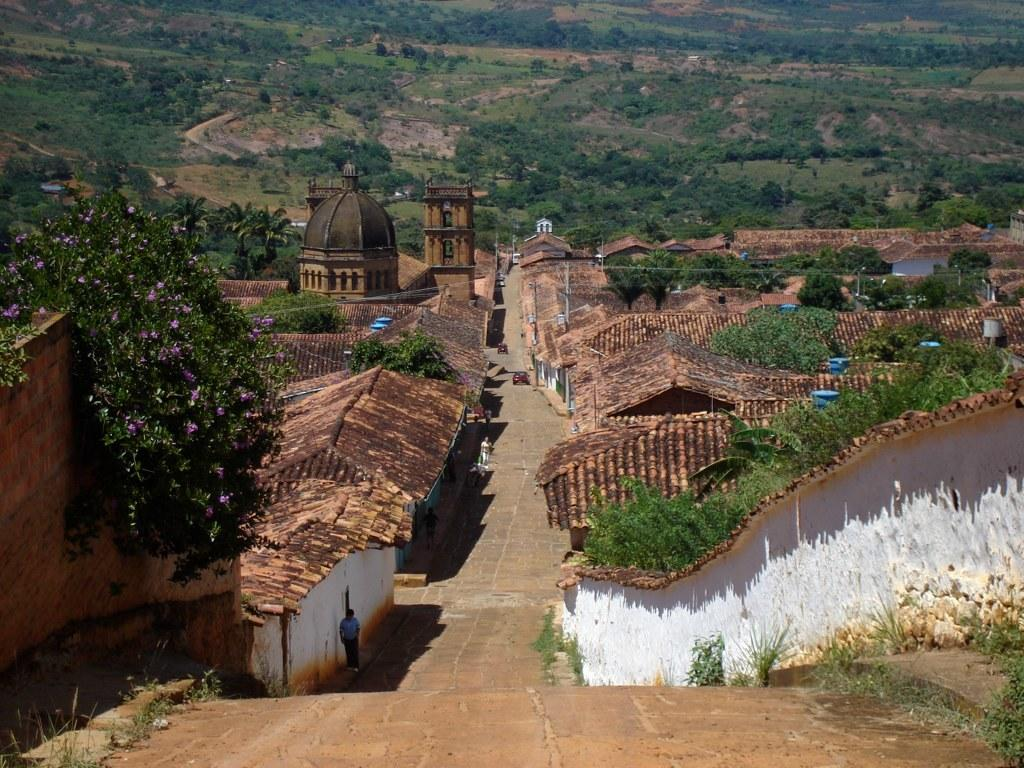What type of structures can be seen in the image? There are houses in the image. What colors are the houses? The houses are in white and brown colors. What type of plants are visible in the image? There are flowers and trees in the image. What color are the flowers? The flowers are in purple color. What color are the trees? The trees are in green color. What time of day is it in the image? The provided facts do not mention the time of day, so it cannot be determined from the image. 